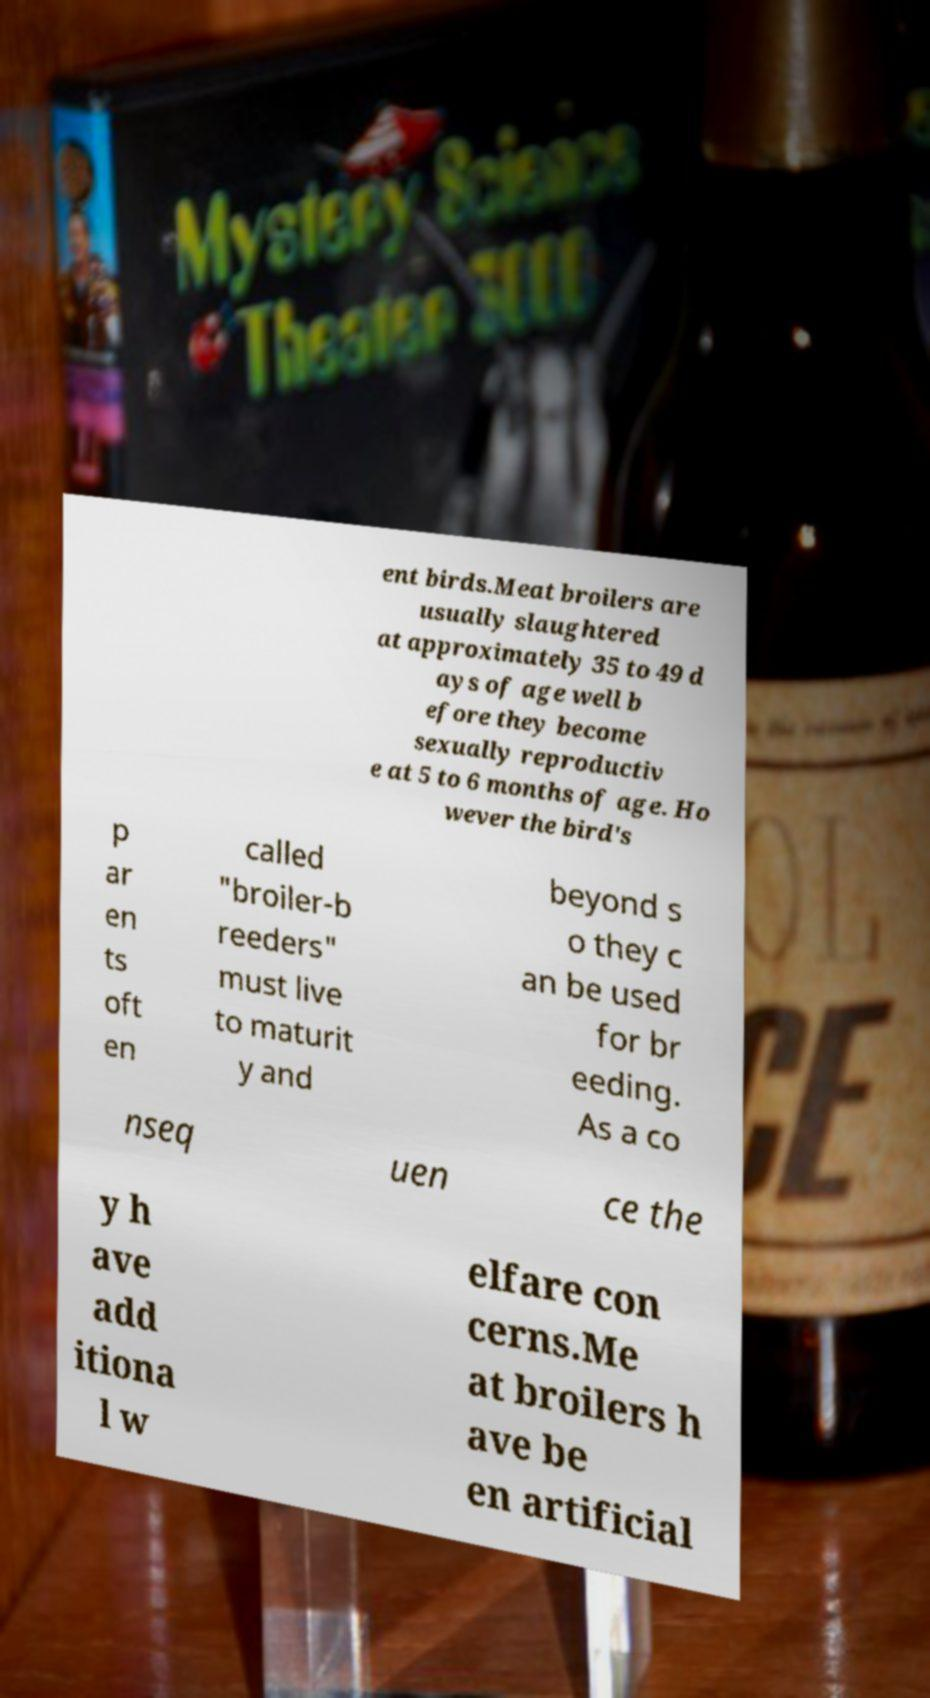There's text embedded in this image that I need extracted. Can you transcribe it verbatim? ent birds.Meat broilers are usually slaughtered at approximately 35 to 49 d ays of age well b efore they become sexually reproductiv e at 5 to 6 months of age. Ho wever the bird's p ar en ts oft en called "broiler-b reeders" must live to maturit y and beyond s o they c an be used for br eeding. As a co nseq uen ce the y h ave add itiona l w elfare con cerns.Me at broilers h ave be en artificial 